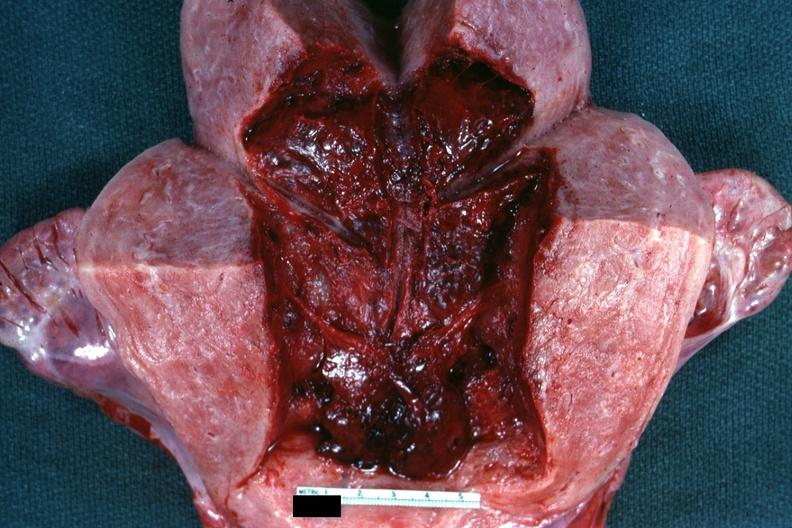when does this image show 18 hours?
Answer the question using a single word or phrase. After cesarean section 